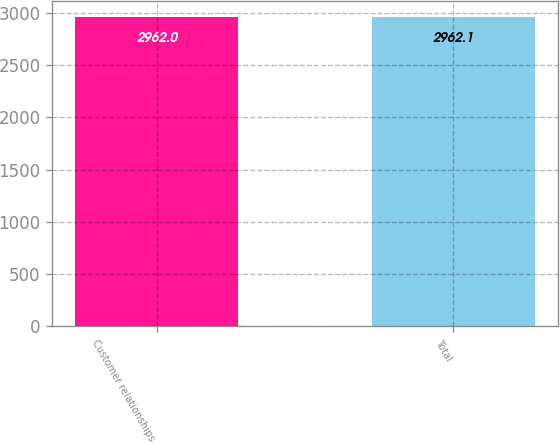<chart> <loc_0><loc_0><loc_500><loc_500><bar_chart><fcel>Customer relationships<fcel>Total<nl><fcel>2962<fcel>2962.1<nl></chart> 